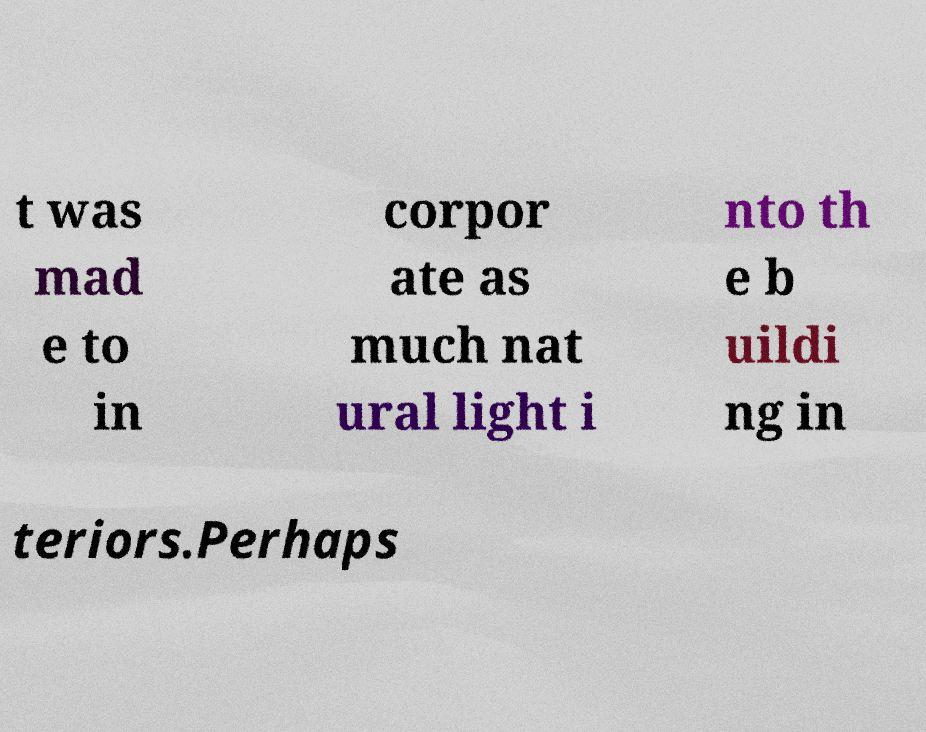I need the written content from this picture converted into text. Can you do that? t was mad e to in corpor ate as much nat ural light i nto th e b uildi ng in teriors.Perhaps 